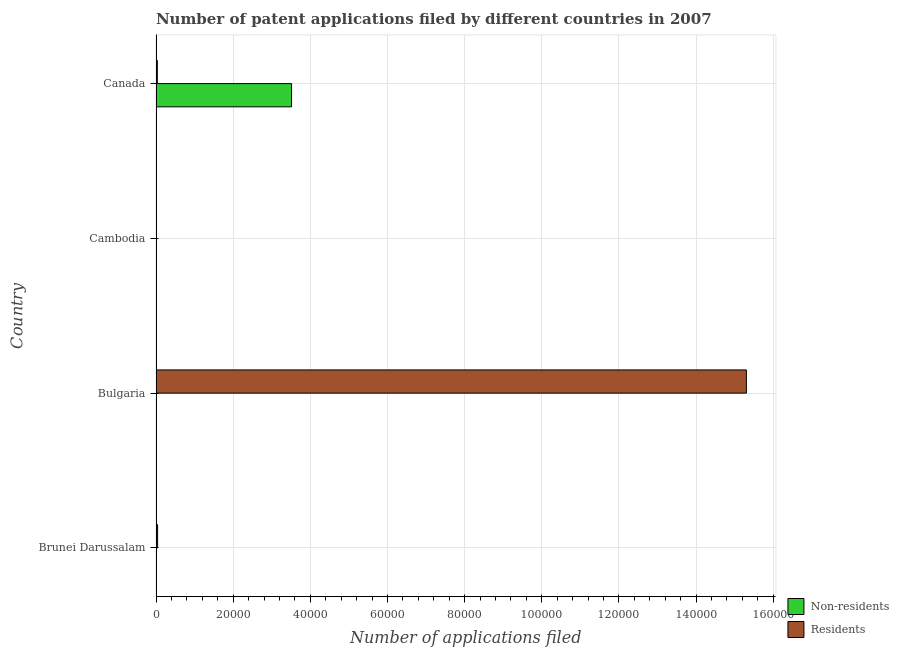How many different coloured bars are there?
Ensure brevity in your answer.  2. How many groups of bars are there?
Your answer should be compact. 4. How many bars are there on the 3rd tick from the top?
Ensure brevity in your answer.  2. How many bars are there on the 1st tick from the bottom?
Give a very brief answer. 2. What is the label of the 1st group of bars from the top?
Offer a very short reply. Canada. What is the number of patent applications by non residents in Canada?
Offer a very short reply. 3.51e+04. Across all countries, what is the maximum number of patent applications by non residents?
Make the answer very short. 3.51e+04. Across all countries, what is the minimum number of patent applications by non residents?
Provide a succinct answer. 13. In which country was the number of patent applications by residents minimum?
Offer a very short reply. Cambodia. What is the total number of patent applications by non residents in the graph?
Make the answer very short. 3.52e+04. What is the difference between the number of patent applications by residents in Brunei Darussalam and that in Canada?
Offer a very short reply. 59. What is the difference between the number of patent applications by residents in Bulgaria and the number of patent applications by non residents in Cambodia?
Your response must be concise. 1.53e+05. What is the average number of patent applications by residents per country?
Offer a terse response. 3.85e+04. What is the difference between the number of patent applications by residents and number of patent applications by non residents in Bulgaria?
Your response must be concise. 1.53e+05. What is the ratio of the number of patent applications by residents in Bulgaria to that in Cambodia?
Make the answer very short. 1195.78. Is the number of patent applications by residents in Cambodia less than that in Canada?
Ensure brevity in your answer.  Yes. What is the difference between the highest and the second highest number of patent applications by residents?
Provide a short and direct response. 1.53e+05. What is the difference between the highest and the lowest number of patent applications by residents?
Your answer should be very brief. 1.53e+05. What does the 1st bar from the top in Brunei Darussalam represents?
Make the answer very short. Residents. What does the 2nd bar from the bottom in Cambodia represents?
Keep it short and to the point. Residents. How many bars are there?
Your response must be concise. 8. Are the values on the major ticks of X-axis written in scientific E-notation?
Provide a succinct answer. No. Does the graph contain any zero values?
Provide a short and direct response. No. Where does the legend appear in the graph?
Your answer should be compact. Bottom right. How many legend labels are there?
Your response must be concise. 2. What is the title of the graph?
Provide a short and direct response. Number of patent applications filed by different countries in 2007. Does "Nonresident" appear as one of the legend labels in the graph?
Ensure brevity in your answer.  No. What is the label or title of the X-axis?
Give a very brief answer. Number of applications filed. What is the label or title of the Y-axis?
Give a very brief answer. Country. What is the Number of applications filed in Residents in Brunei Darussalam?
Your answer should be very brief. 403. What is the Number of applications filed in Residents in Bulgaria?
Give a very brief answer. 1.53e+05. What is the Number of applications filed of Residents in Cambodia?
Your response must be concise. 128. What is the Number of applications filed of Non-residents in Canada?
Your answer should be very brief. 3.51e+04. What is the Number of applications filed of Residents in Canada?
Provide a short and direct response. 344. Across all countries, what is the maximum Number of applications filed in Non-residents?
Offer a terse response. 3.51e+04. Across all countries, what is the maximum Number of applications filed in Residents?
Offer a terse response. 1.53e+05. Across all countries, what is the minimum Number of applications filed of Residents?
Make the answer very short. 128. What is the total Number of applications filed in Non-residents in the graph?
Your response must be concise. 3.52e+04. What is the total Number of applications filed of Residents in the graph?
Make the answer very short. 1.54e+05. What is the difference between the Number of applications filed in Non-residents in Brunei Darussalam and that in Bulgaria?
Give a very brief answer. 36. What is the difference between the Number of applications filed of Residents in Brunei Darussalam and that in Bulgaria?
Make the answer very short. -1.53e+05. What is the difference between the Number of applications filed in Residents in Brunei Darussalam and that in Cambodia?
Keep it short and to the point. 275. What is the difference between the Number of applications filed of Non-residents in Brunei Darussalam and that in Canada?
Provide a short and direct response. -3.51e+04. What is the difference between the Number of applications filed of Residents in Bulgaria and that in Cambodia?
Provide a short and direct response. 1.53e+05. What is the difference between the Number of applications filed of Non-residents in Bulgaria and that in Canada?
Your answer should be very brief. -3.51e+04. What is the difference between the Number of applications filed in Residents in Bulgaria and that in Canada?
Your response must be concise. 1.53e+05. What is the difference between the Number of applications filed of Non-residents in Cambodia and that in Canada?
Give a very brief answer. -3.51e+04. What is the difference between the Number of applications filed in Residents in Cambodia and that in Canada?
Your response must be concise. -216. What is the difference between the Number of applications filed in Non-residents in Brunei Darussalam and the Number of applications filed in Residents in Bulgaria?
Offer a very short reply. -1.53e+05. What is the difference between the Number of applications filed of Non-residents in Brunei Darussalam and the Number of applications filed of Residents in Cambodia?
Offer a terse response. -64. What is the difference between the Number of applications filed in Non-residents in Brunei Darussalam and the Number of applications filed in Residents in Canada?
Provide a succinct answer. -280. What is the difference between the Number of applications filed of Non-residents in Bulgaria and the Number of applications filed of Residents in Cambodia?
Offer a very short reply. -100. What is the difference between the Number of applications filed of Non-residents in Bulgaria and the Number of applications filed of Residents in Canada?
Your answer should be compact. -316. What is the difference between the Number of applications filed in Non-residents in Cambodia and the Number of applications filed in Residents in Canada?
Offer a terse response. -331. What is the average Number of applications filed of Non-residents per country?
Your response must be concise. 8809.5. What is the average Number of applications filed of Residents per country?
Keep it short and to the point. 3.85e+04. What is the difference between the Number of applications filed of Non-residents and Number of applications filed of Residents in Brunei Darussalam?
Provide a short and direct response. -339. What is the difference between the Number of applications filed in Non-residents and Number of applications filed in Residents in Bulgaria?
Ensure brevity in your answer.  -1.53e+05. What is the difference between the Number of applications filed in Non-residents and Number of applications filed in Residents in Cambodia?
Ensure brevity in your answer.  -115. What is the difference between the Number of applications filed in Non-residents and Number of applications filed in Residents in Canada?
Provide a succinct answer. 3.48e+04. What is the ratio of the Number of applications filed in Non-residents in Brunei Darussalam to that in Bulgaria?
Give a very brief answer. 2.29. What is the ratio of the Number of applications filed in Residents in Brunei Darussalam to that in Bulgaria?
Offer a very short reply. 0. What is the ratio of the Number of applications filed in Non-residents in Brunei Darussalam to that in Cambodia?
Provide a succinct answer. 4.92. What is the ratio of the Number of applications filed of Residents in Brunei Darussalam to that in Cambodia?
Your answer should be very brief. 3.15. What is the ratio of the Number of applications filed in Non-residents in Brunei Darussalam to that in Canada?
Give a very brief answer. 0. What is the ratio of the Number of applications filed in Residents in Brunei Darussalam to that in Canada?
Your response must be concise. 1.17. What is the ratio of the Number of applications filed in Non-residents in Bulgaria to that in Cambodia?
Your answer should be very brief. 2.15. What is the ratio of the Number of applications filed in Residents in Bulgaria to that in Cambodia?
Offer a terse response. 1195.78. What is the ratio of the Number of applications filed in Non-residents in Bulgaria to that in Canada?
Your answer should be very brief. 0. What is the ratio of the Number of applications filed in Residents in Bulgaria to that in Canada?
Make the answer very short. 444.94. What is the ratio of the Number of applications filed of Non-residents in Cambodia to that in Canada?
Offer a terse response. 0. What is the ratio of the Number of applications filed of Residents in Cambodia to that in Canada?
Ensure brevity in your answer.  0.37. What is the difference between the highest and the second highest Number of applications filed of Non-residents?
Your answer should be compact. 3.51e+04. What is the difference between the highest and the second highest Number of applications filed in Residents?
Offer a very short reply. 1.53e+05. What is the difference between the highest and the lowest Number of applications filed in Non-residents?
Offer a very short reply. 3.51e+04. What is the difference between the highest and the lowest Number of applications filed in Residents?
Your answer should be very brief. 1.53e+05. 